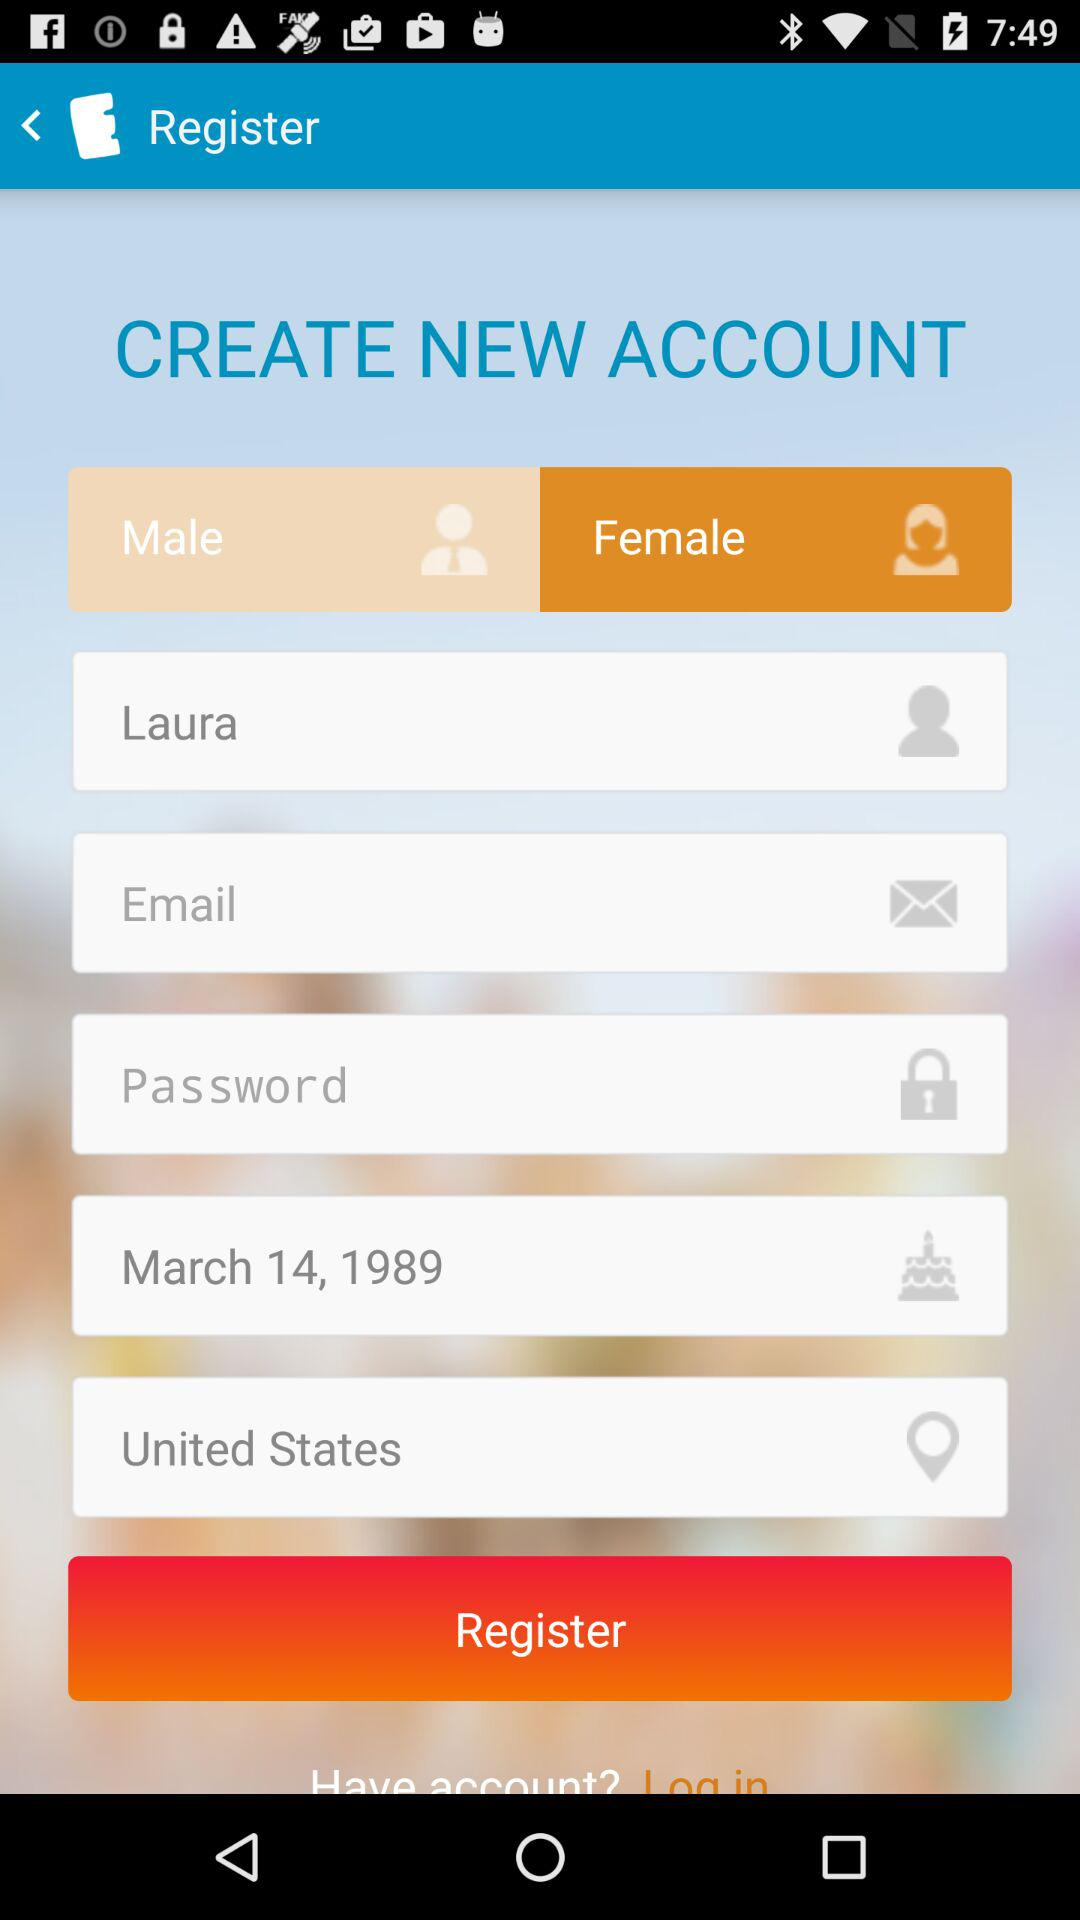What is the user name? The user name is Laura. 